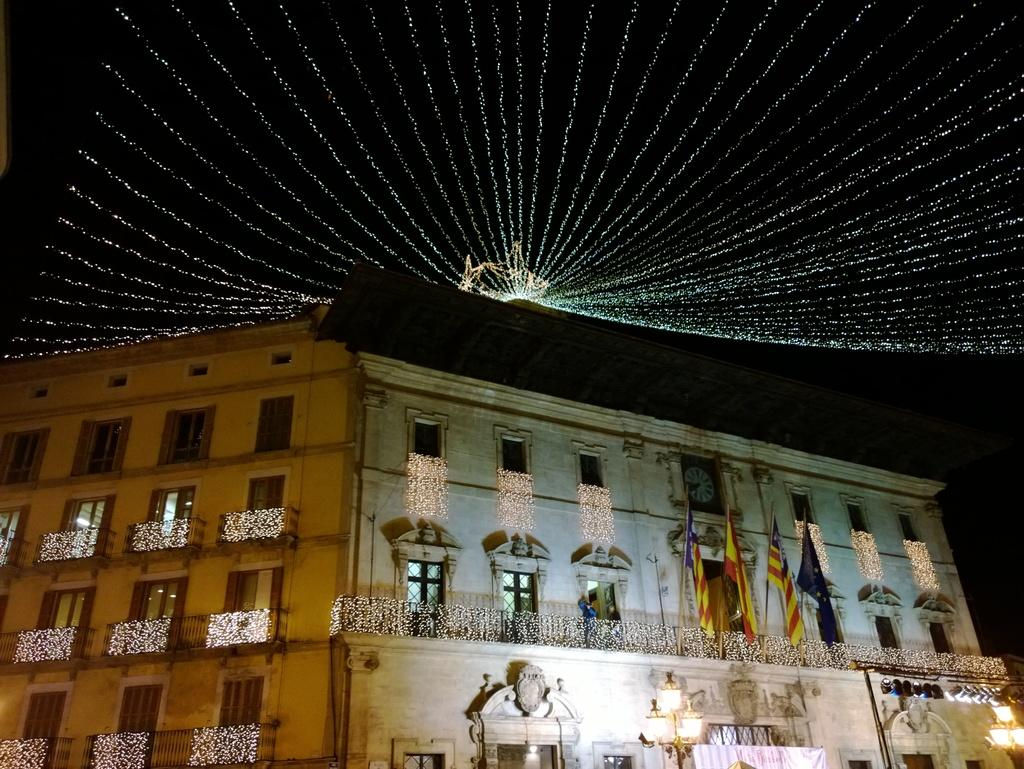What is located at the bottom of the image? There is a building at the bottom of the image. What can be seen on the building? There are flags on the building. Can you touch the insurance policy in the image? There is no insurance policy present in the image, and therefore it cannot be touched. 